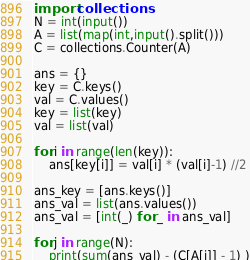<code> <loc_0><loc_0><loc_500><loc_500><_Python_>import collections
N = int(input())
A = list(map(int,input().split()))
C = collections.Counter(A)

ans = {}
key = C.keys()
val = C.values()
key = list(key)
val = list(val)

for i in range(len(key)):
    ans[key[i]] = val[i] * (val[i]-1) //2

ans_key = [ans.keys()]
ans_val = list(ans.values())
ans_val = [int(_) for _ in ans_val]

for j in range(N):
    print(sum(ans_val) - (C[A[j]] - 1) )
</code> 